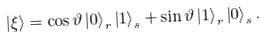Convert formula to latex. <formula><loc_0><loc_0><loc_500><loc_500>\left | \xi \right \rangle = \cos \vartheta \left | 0 \right \rangle _ { r } \left | 1 \right \rangle _ { s } + \sin \vartheta \left | 1 \right \rangle _ { r } \left | 0 \right \rangle _ { s } .</formula> 